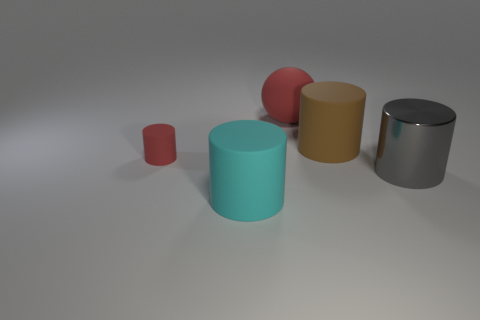What color is the big cylinder to the left of the red matte thing that is behind the tiny rubber cylinder?
Make the answer very short. Cyan. What number of other things are there of the same material as the big brown object
Your response must be concise. 3. How many red matte objects are in front of the large matte ball that is on the right side of the tiny red cylinder?
Your response must be concise. 1. Are there any other things that have the same shape as the large red matte object?
Give a very brief answer. No. Does the cylinder in front of the big gray shiny object have the same color as the rubber thing right of the large red matte thing?
Give a very brief answer. No. Is the number of large cyan matte objects less than the number of large red matte cubes?
Offer a terse response. No. There is a large thing that is right of the big cylinder that is behind the tiny matte cylinder; what is its shape?
Provide a succinct answer. Cylinder. Are there any other things that have the same size as the red cylinder?
Make the answer very short. No. The large matte object in front of the big cylinder on the right side of the large brown object that is behind the cyan thing is what shape?
Your response must be concise. Cylinder. How many things are large cylinders behind the large gray cylinder or rubber things that are in front of the large brown object?
Offer a very short reply. 3. 